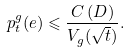<formula> <loc_0><loc_0><loc_500><loc_500>p _ { t } ^ { g } ( e ) \leqslant \frac { C \left ( D \right ) } { V _ { g } ( \sqrt { t } ) } .</formula> 